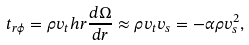Convert formula to latex. <formula><loc_0><loc_0><loc_500><loc_500>t _ { r \phi } = \rho v _ { t } h r \frac { d \Omega } { d r } \approx \rho v _ { t } v _ { s } = - \alpha \rho v _ { s } ^ { 2 } ,</formula> 